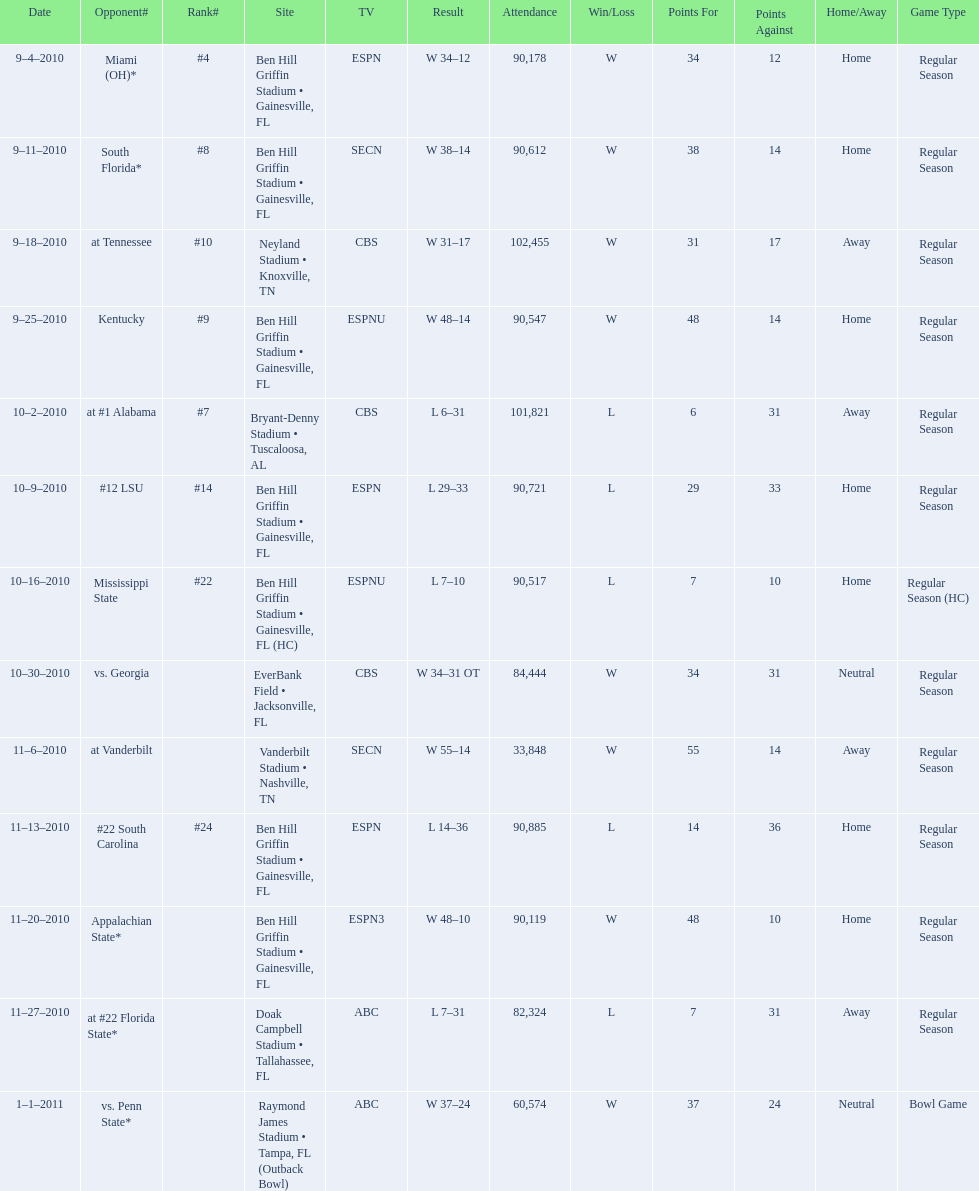Write the full table. {'header': ['Date', 'Opponent#', 'Rank#', 'Site', 'TV', 'Result', 'Attendance', 'Win/Loss', 'Points For', 'Points Against', 'Home/Away', 'Game Type'], 'rows': [['9–4–2010', 'Miami (OH)*', '#4', 'Ben Hill Griffin Stadium • Gainesville, FL', 'ESPN', 'W\xa034–12', '90,178', 'W', '34', '12', 'Home', 'Regular Season'], ['9–11–2010', 'South Florida*', '#8', 'Ben Hill Griffin Stadium • Gainesville, FL', 'SECN', 'W\xa038–14', '90,612', 'W', '38', '14', 'Home', 'Regular Season'], ['9–18–2010', 'at\xa0Tennessee', '#10', 'Neyland Stadium • Knoxville, TN', 'CBS', 'W\xa031–17', '102,455', 'W', '31', '17', 'Away', 'Regular Season'], ['9–25–2010', 'Kentucky', '#9', 'Ben Hill Griffin Stadium • Gainesville, FL', 'ESPNU', 'W\xa048–14', '90,547', 'W', '48', '14', 'Home', 'Regular Season'], ['10–2–2010', 'at\xa0#1\xa0Alabama', '#7', 'Bryant-Denny Stadium • Tuscaloosa, AL', 'CBS', 'L\xa06–31', '101,821', 'L', '6', '31', 'Away', 'Regular Season'], ['10–9–2010', '#12\xa0LSU', '#14', 'Ben Hill Griffin Stadium • Gainesville, FL', 'ESPN', 'L\xa029–33', '90,721', 'L', '29', '33', 'Home', 'Regular Season'], ['10–16–2010', 'Mississippi State', '#22', 'Ben Hill Griffin Stadium • Gainesville, FL (HC)', 'ESPNU', 'L\xa07–10', '90,517', 'L', '7', '10', 'Home', 'Regular Season (HC)'], ['10–30–2010', 'vs.\xa0Georgia', '', 'EverBank Field • Jacksonville, FL', 'CBS', 'W\xa034–31\xa0OT', '84,444', 'W', '34', '31', 'Neutral', 'Regular Season'], ['11–6–2010', 'at\xa0Vanderbilt', '', 'Vanderbilt Stadium • Nashville, TN', 'SECN', 'W\xa055–14', '33,848', 'W', '55', '14', 'Away', 'Regular Season'], ['11–13–2010', '#22\xa0South Carolina', '#24', 'Ben Hill Griffin Stadium • Gainesville, FL', 'ESPN', 'L\xa014–36', '90,885', 'L', '14', '36', 'Home', 'Regular Season'], ['11–20–2010', 'Appalachian State*', '', 'Ben Hill Griffin Stadium • Gainesville, FL', 'ESPN3', 'W\xa048–10', '90,119', 'W', '48', '10', 'Home', 'Regular Season'], ['11–27–2010', 'at\xa0#22\xa0Florida State*', '', 'Doak Campbell Stadium • Tallahassee, FL', 'ABC', 'L\xa07–31', '82,324', 'L', '7', '31', 'Away', 'Regular Season'], ['1–1–2011', 'vs.\xa0Penn State*', '', 'Raymond James Stadium • Tampa, FL (Outback Bowl)', 'ABC', 'W\xa037–24', '60,574', 'W', '37', '24', 'Neutral', 'Bowl Game']]} What was the most the university of florida won by? 41 points. 